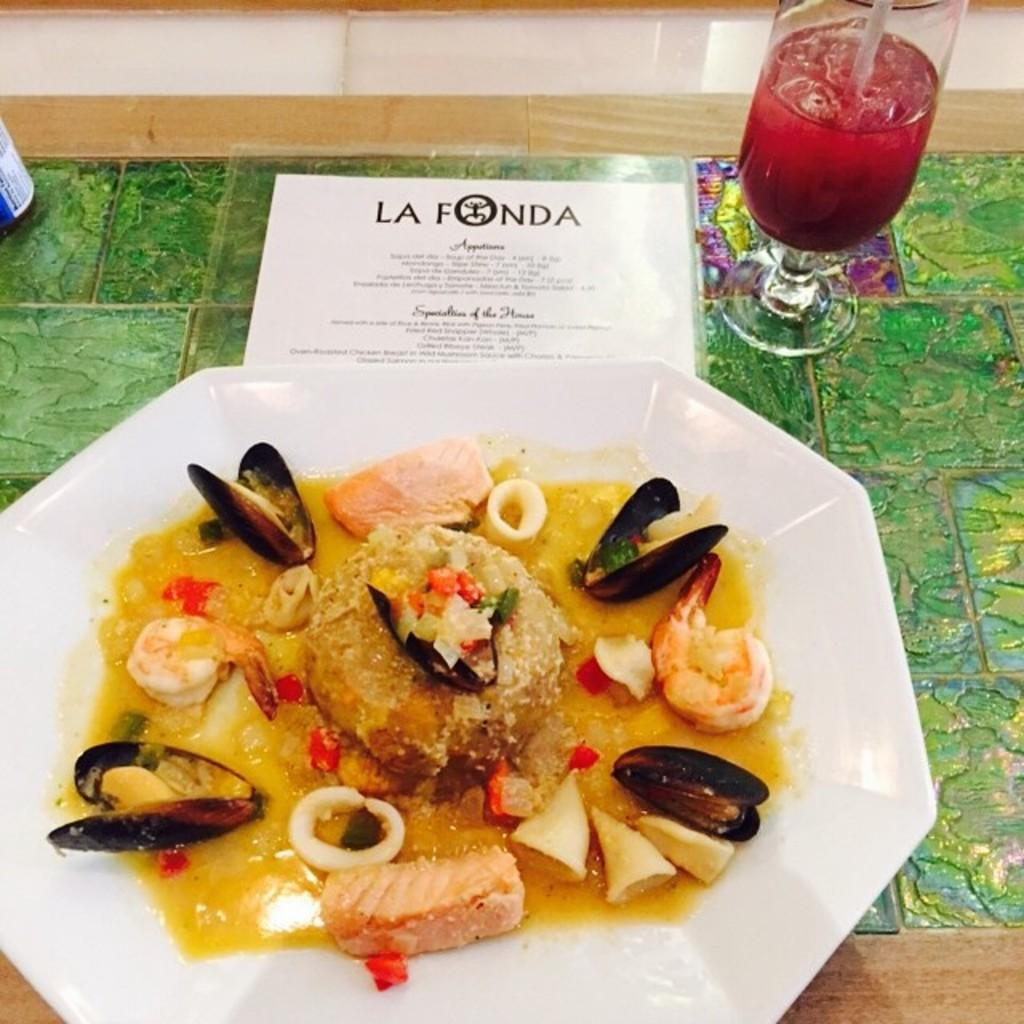What type of food is present on the plate in the image? The food contains shells, meat, and cream in a plate. Where is the plate located in the image? The plate is placed on a table. What else can be seen on the table besides the plate? There is a paper and a glass of juice with a straw on the table. In which direction is the toothpaste tube facing in the image? There is no toothpaste tube present in the image. 